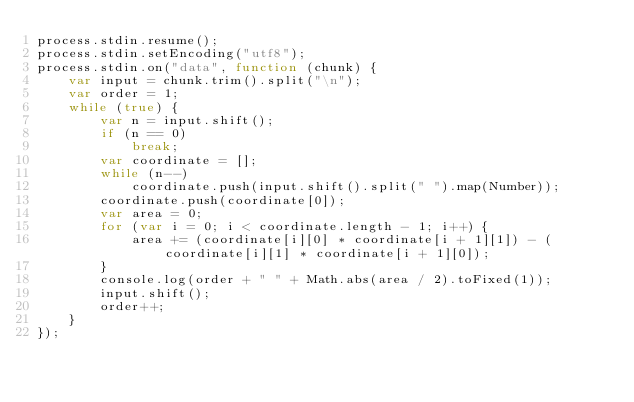Convert code to text. <code><loc_0><loc_0><loc_500><loc_500><_JavaScript_>process.stdin.resume();
process.stdin.setEncoding("utf8");
process.stdin.on("data", function (chunk) {
    var input = chunk.trim().split("\n");
    var order = 1;
    while (true) {
        var n = input.shift();
        if (n == 0)
            break;
        var coordinate = [];
        while (n--)
            coordinate.push(input.shift().split(" ").map(Number));
        coordinate.push(coordinate[0]);
        var area = 0;
        for (var i = 0; i < coordinate.length - 1; i++) {
            area += (coordinate[i][0] * coordinate[i + 1][1]) - (coordinate[i][1] * coordinate[i + 1][0]);
        }
        console.log(order + " " + Math.abs(area / 2).toFixed(1));
        input.shift();
        order++;
    }
});</code> 